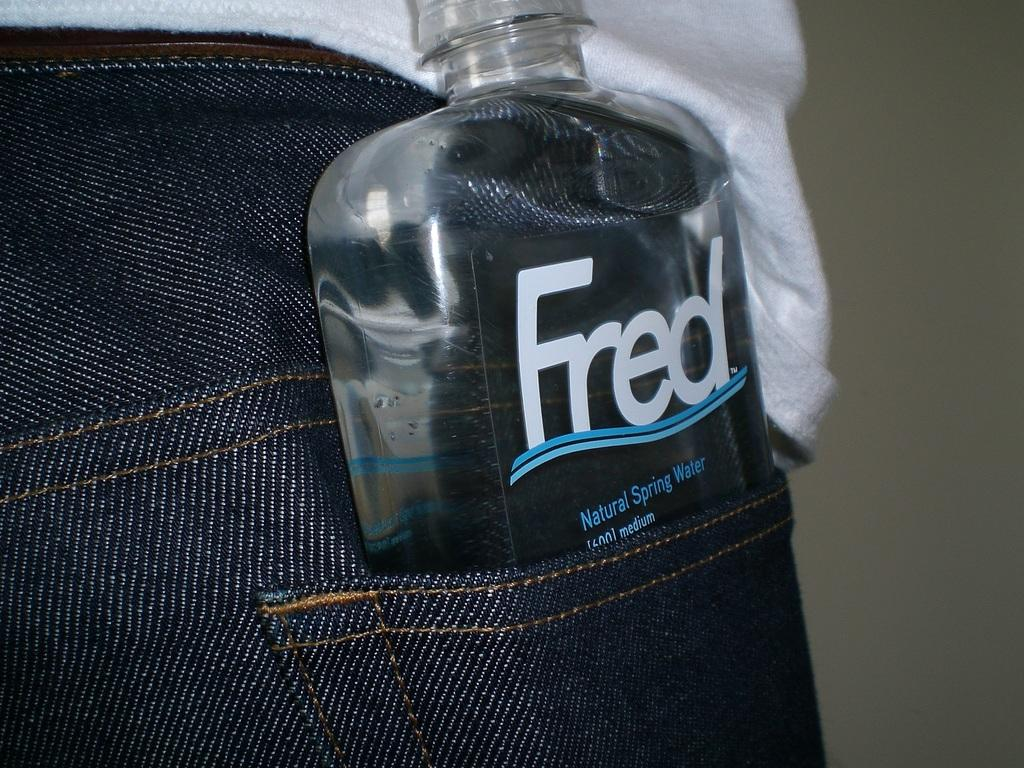What object is located in the pocket and shirt in the image? There is a bottle in the pocket and shirt in the image. What type of structure can be seen in the background of the image? There is a wall in the image. What type of secretary is sitting behind the wall in the image? There is no secretary present in the image; it only features a wall and a bottle in the pocket and shirt. 